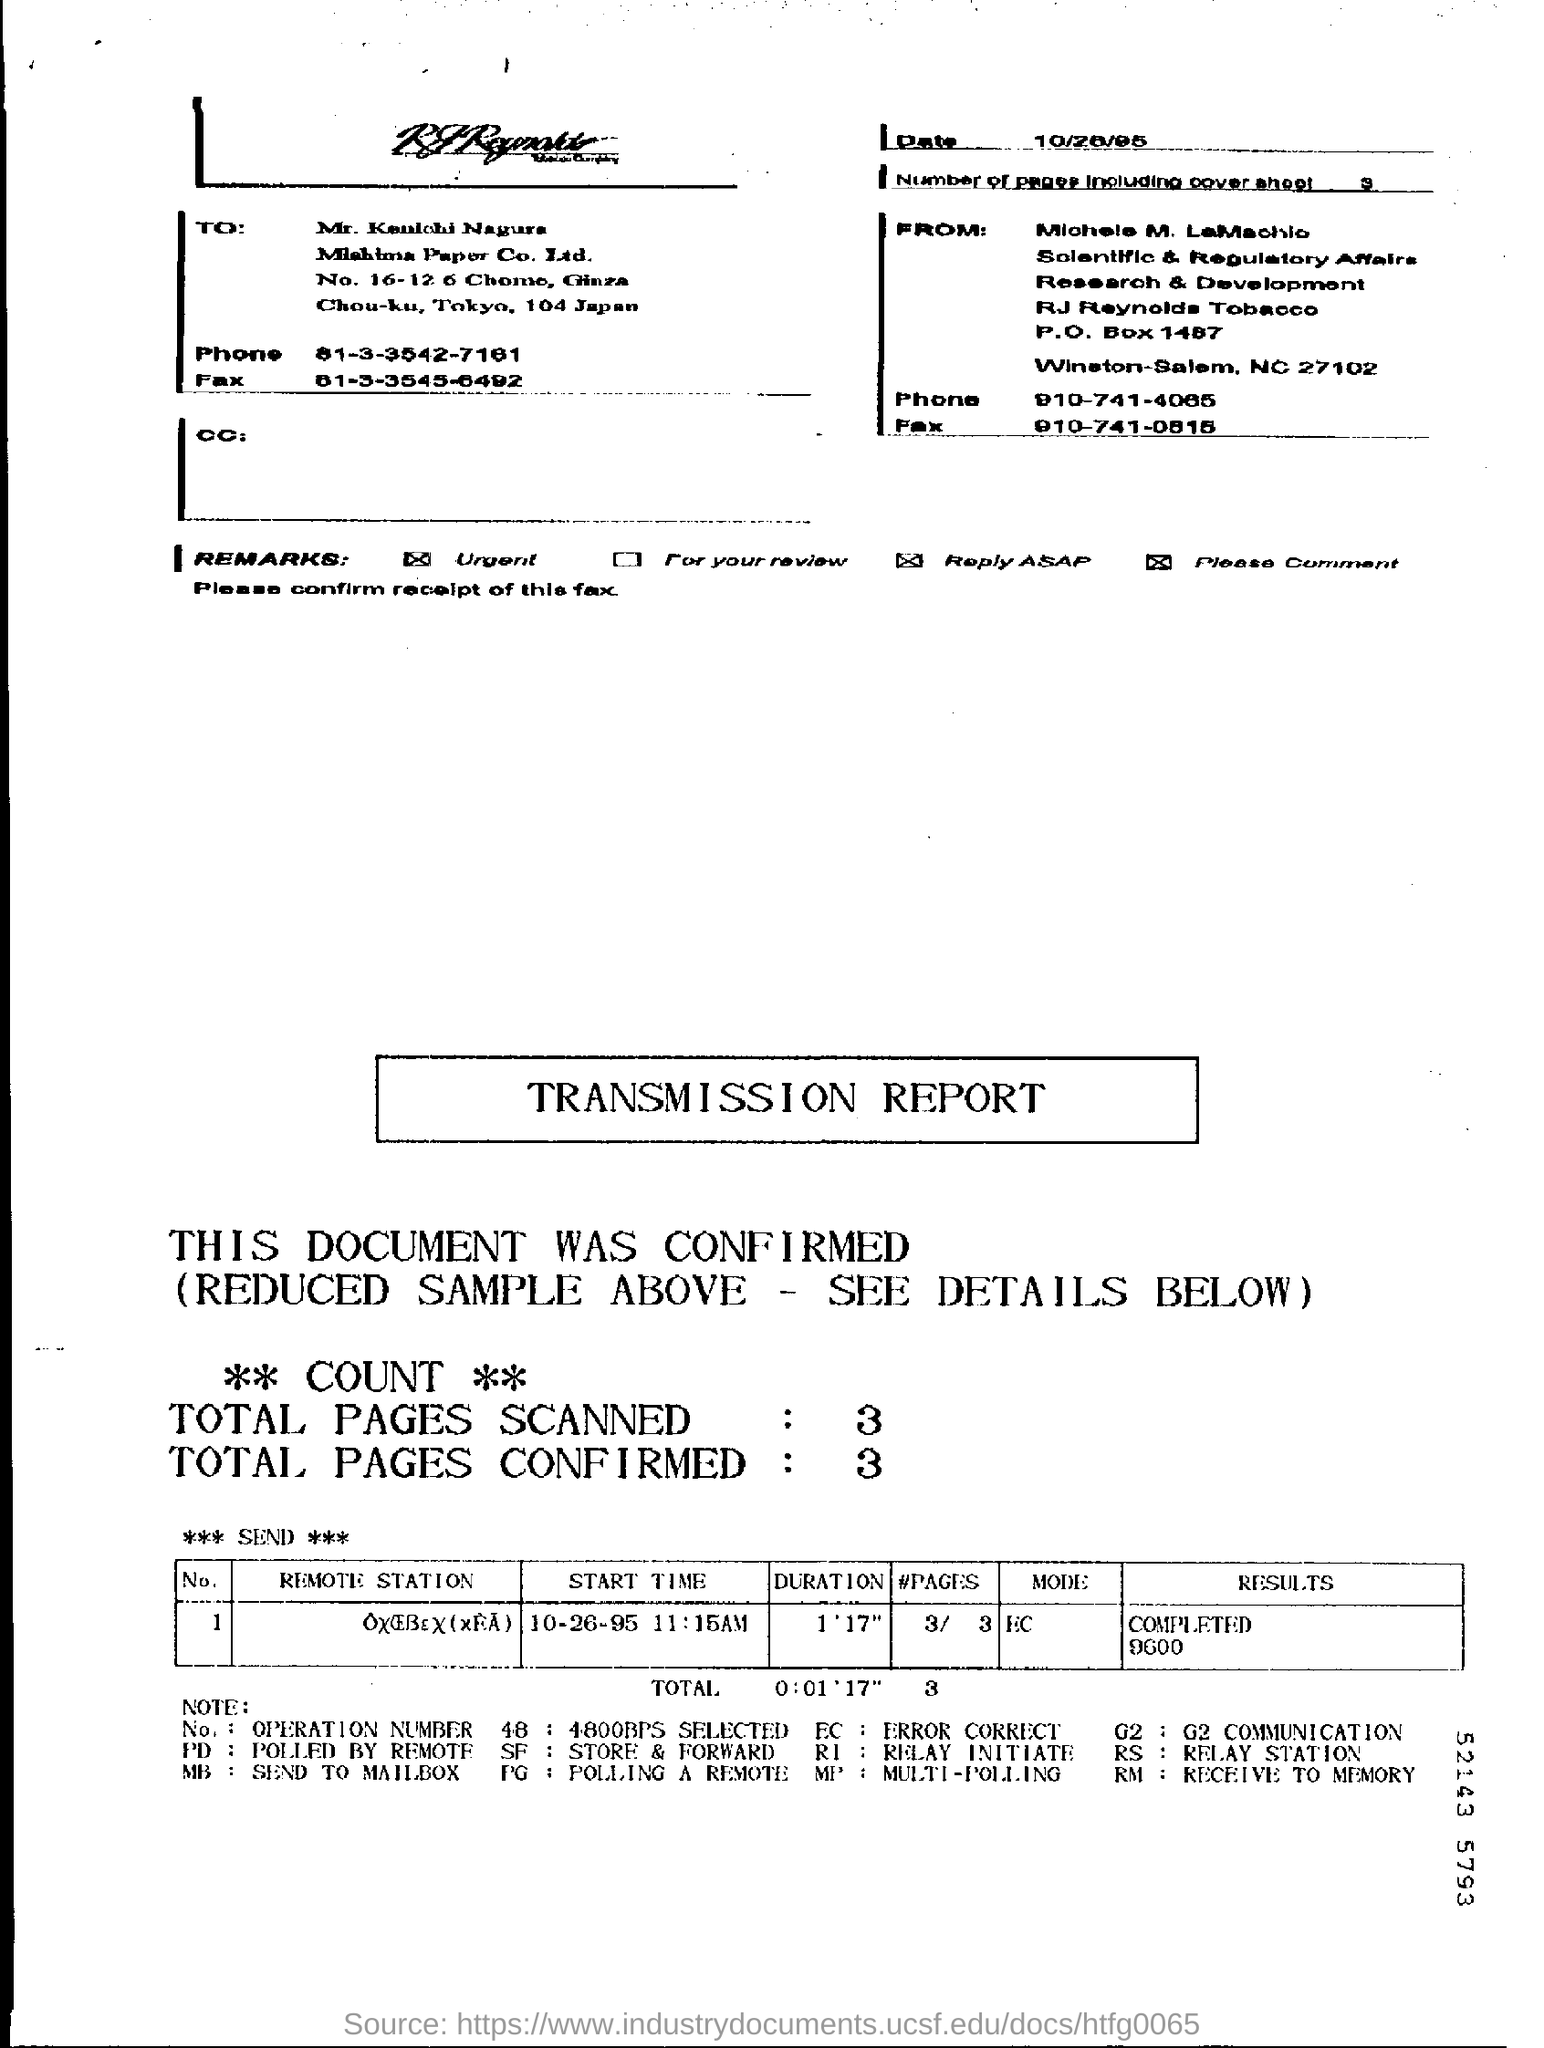What is the number of pages in the fax including cover sheet?
Your response must be concise. 3. What is the mode given in the transmission report?
Make the answer very short. EC. What is the duration mentioned in the transmission report?
Give a very brief answer. 1'17". What is the phone no of Michele M. LaMachio?
Offer a terse response. 910-741-4065. 